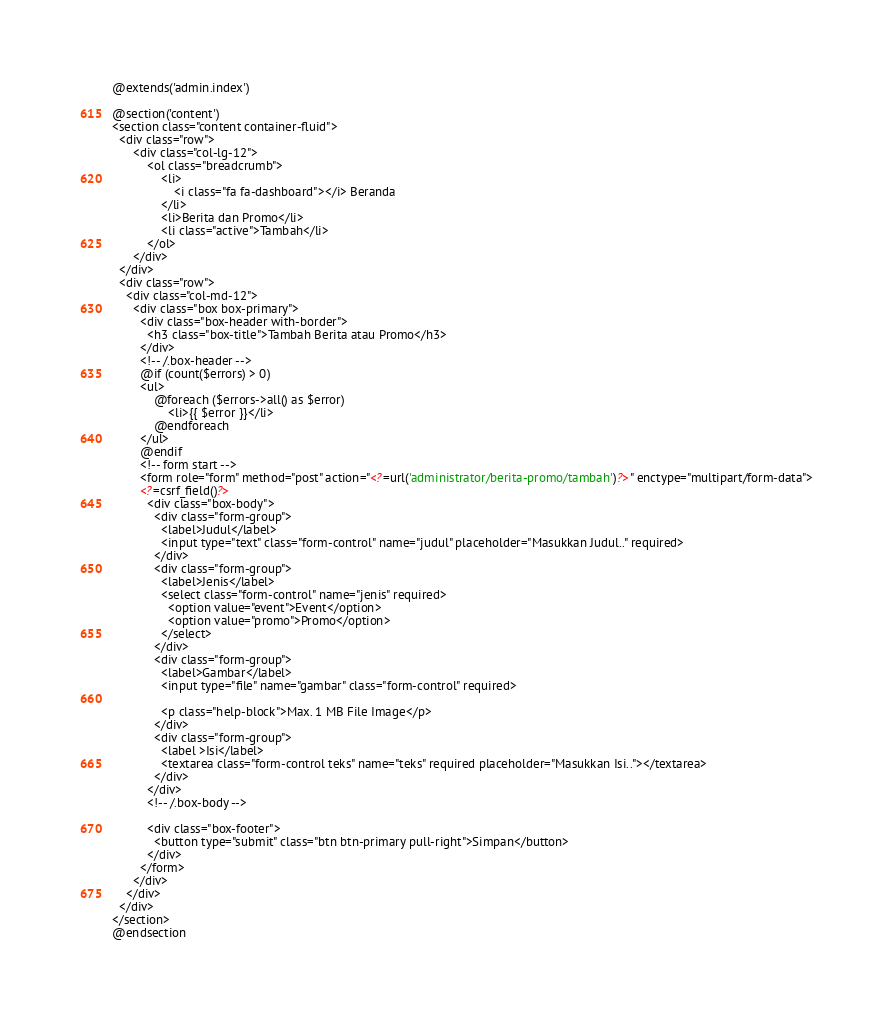Convert code to text. <code><loc_0><loc_0><loc_500><loc_500><_PHP_>@extends('admin.index')

@section('content')
<section class="content container-fluid">
  <div class="row">
      <div class="col-lg-12">
          <ol class="breadcrumb">
              <li>
                  <i class="fa fa-dashboard"></i> Beranda
              </li>
              <li>Berita dan Promo</li>
              <li class="active">Tambah</li>
          </ol>
      </div>
  </div>
  <div class="row">
    <div class="col-md-12">
      <div class="box box-primary">
        <div class="box-header with-border">
          <h3 class="box-title">Tambah Berita atau Promo</h3>
        </div>
        <!-- /.box-header -->
        @if (count($errors) > 0)
        <ul>
            @foreach ($errors->all() as $error)
                <li>{{ $error }}</li>
            @endforeach
        </ul>
        @endif
        <!-- form start -->
        <form role="form" method="post" action="<?=url('administrator/berita-promo/tambah')?>" enctype="multipart/form-data">
        <?=csrf_field()?>
          <div class="box-body">
            <div class="form-group">
              <label>Judul</label>
              <input type="text" class="form-control" name="judul" placeholder="Masukkan Judul.." required>
            </div>
            <div class="form-group">
              <label>Jenis</label>
              <select class="form-control" name="jenis" required>
                <option value="event">Event</option>
                <option value="promo">Promo</option>
              </select>
            </div>
            <div class="form-group">
              <label>Gambar</label>
              <input type="file" name="gambar" class="form-control" required>

              <p class="help-block">Max. 1 MB File Image</p>
            </div>
            <div class="form-group">
              <label >Isi</label>
              <textarea class="form-control teks" name="teks" required placeholder="Masukkan Isi.."></textarea>
            </div>
          </div>
          <!-- /.box-body -->

          <div class="box-footer">
            <button type="submit" class="btn btn-primary pull-right">Simpan</button>
          </div>
        </form>
      </div>
    </div>
  </div>
</section>
@endsection</code> 